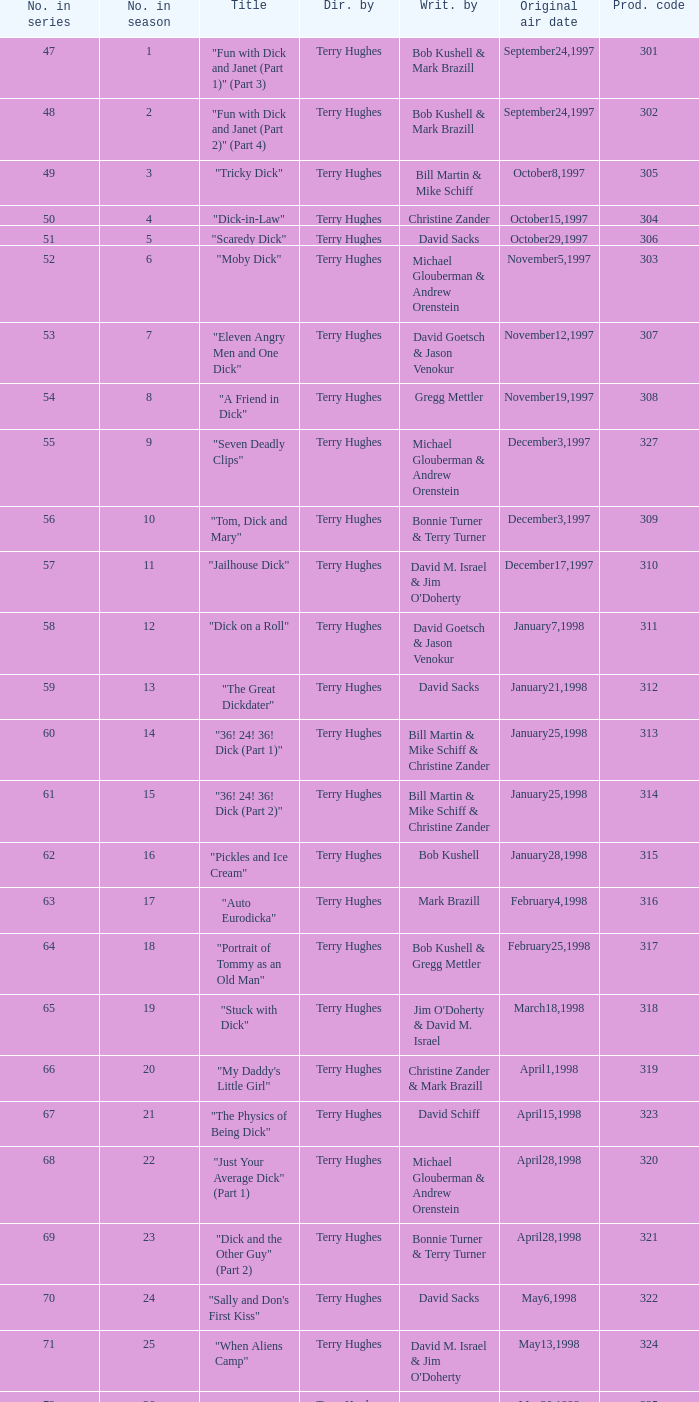What is the original air date of the episode with production code is 319? April1,1998. 